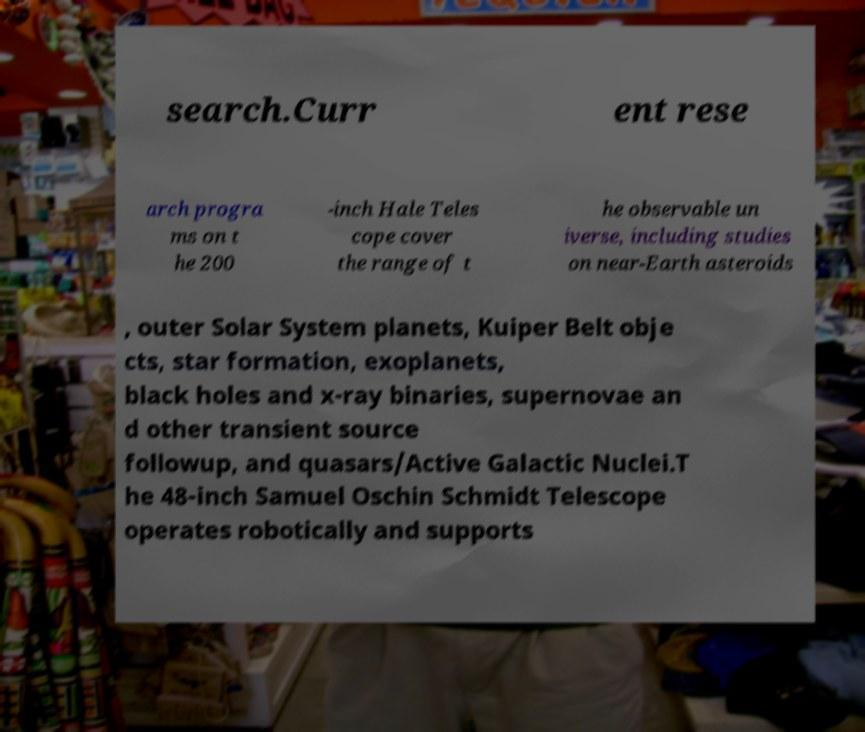I need the written content from this picture converted into text. Can you do that? search.Curr ent rese arch progra ms on t he 200 -inch Hale Teles cope cover the range of t he observable un iverse, including studies on near-Earth asteroids , outer Solar System planets, Kuiper Belt obje cts, star formation, exoplanets, black holes and x-ray binaries, supernovae an d other transient source followup, and quasars/Active Galactic Nuclei.T he 48-inch Samuel Oschin Schmidt Telescope operates robotically and supports 